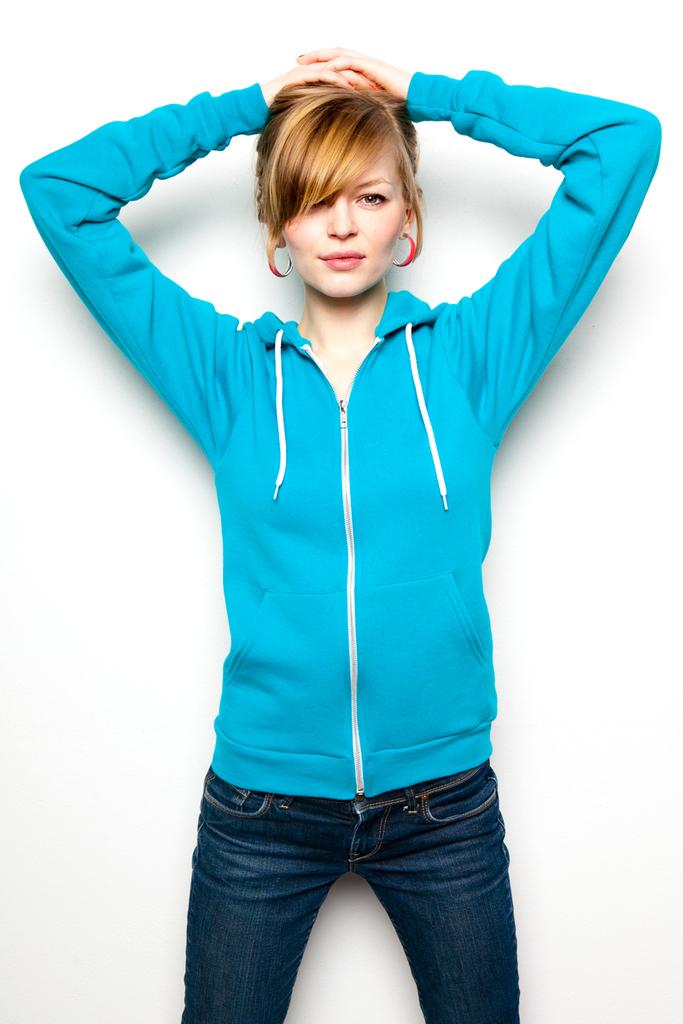Who is the main subject in the image? There is a woman in the image. What is the background of the image? The woman is standing in front of a white background. What is the woman wearing? The woman is wearing a blue sweater and jeans. What is the woman doing in the image? The woman is posing for the photo. What type of destruction can be seen in the image? There is no destruction present in the image; it features a woman posing for a photo in front of a white background. How many trees are visible in the image? There are no trees visible in the image. 